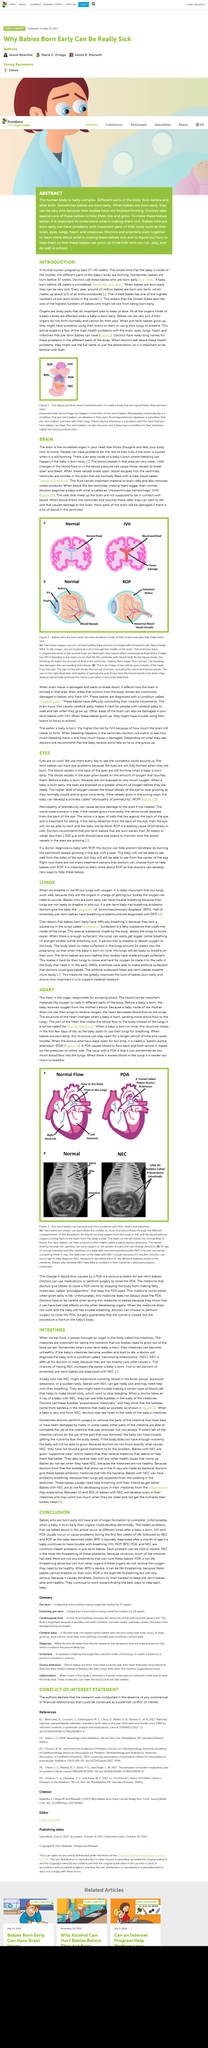Highlight a few significant elements in this photo. It is estimated that approximately half of extremely pre-term babies experience breathing difficulties. Intestines play a crucial role in absorbing the essential nutrients required for growth from the food we consume. It is estimated that approximately five to ten percent of extremely pre-term babies are diagnosed with necrotizing enterocolitis. Necrotizing enterocolitis (NEC) is a condition that occurs when a baby's intestines become swollen and start to die. According to estimates, approximately 15 million pre-term babies are born each year worldwide. 